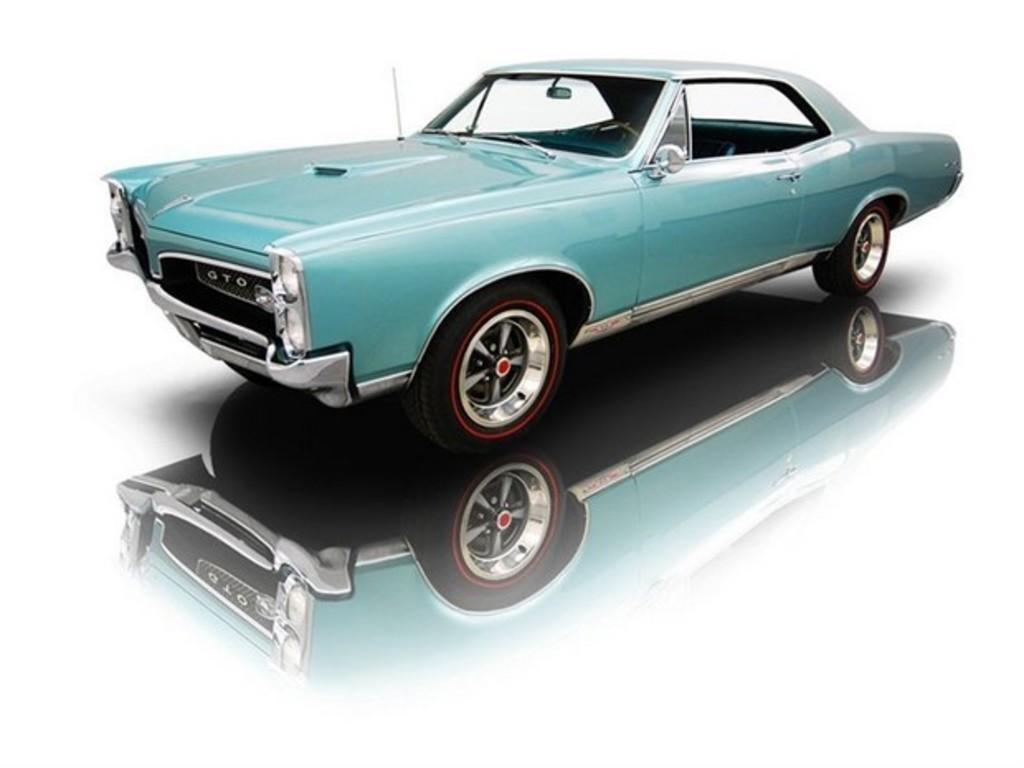Please provide a concise description of this image. In this image I can see a car in blue color and I can see background in white color. 